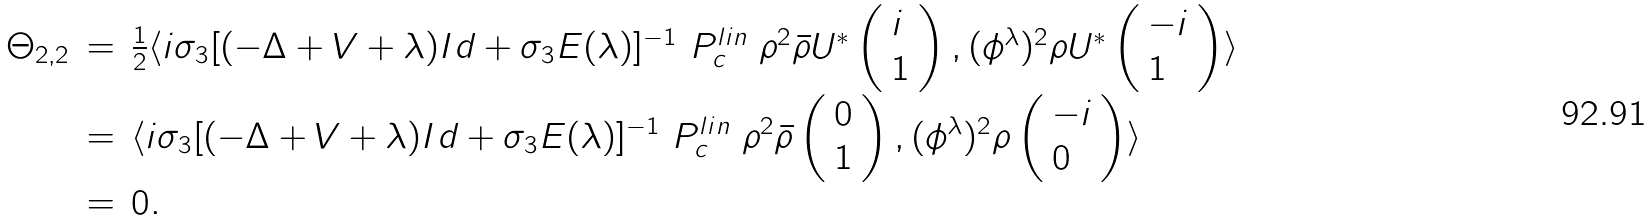Convert formula to latex. <formula><loc_0><loc_0><loc_500><loc_500>\begin{array} { l l l } \Theta _ { 2 , 2 } & = & \frac { 1 } { 2 } \langle i \sigma _ { 3 } [ ( - \Delta + V + \lambda ) I d + \sigma _ { 3 } E ( \lambda ) ] ^ { - 1 } \ P _ { c } ^ { l i n } \ \rho ^ { 2 } \bar { \rho } U ^ { * } \left ( \begin{array} { l l l } i \\ 1 \end{array} \right ) , ( \phi ^ { \lambda } ) ^ { 2 } \rho U ^ { * } \left ( \begin{array} { l l l } - i \\ 1 \end{array} \right ) \rangle \\ & = & \langle i \sigma _ { 3 } [ ( - \Delta + V + \lambda ) I d + \sigma _ { 3 } E ( \lambda ) ] ^ { - 1 } \ P _ { c } ^ { l i n } \ \rho ^ { 2 } \bar { \rho } \left ( \begin{array} { l l l } 0 \\ 1 \end{array} \right ) , ( \phi ^ { \lambda } ) ^ { 2 } \rho \left ( \begin{array} { l l l } - i \\ 0 \end{array} \right ) \rangle \\ & = & 0 . \end{array}</formula> 